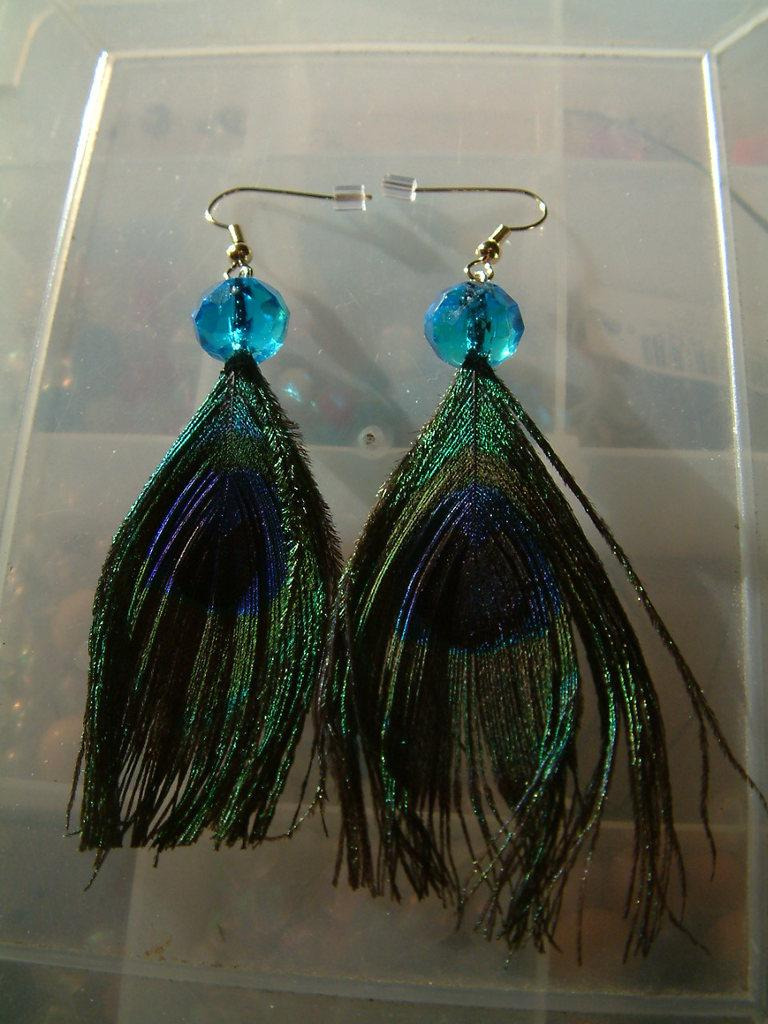What type of earrings are featured in the image? There are peacock feather earrings in the image. What color are the earrings? The earrings are green in color. Where are the earrings placed in the image? The earrings are placed on a plastic box. How many spiders are crawling on the earrings in the image? There are no spiders present in the image; it only features peacock feather earrings and a plastic box. What type of currency is visible on the earrings in the image? There is no money or currency visible on the earrings or in the image. 